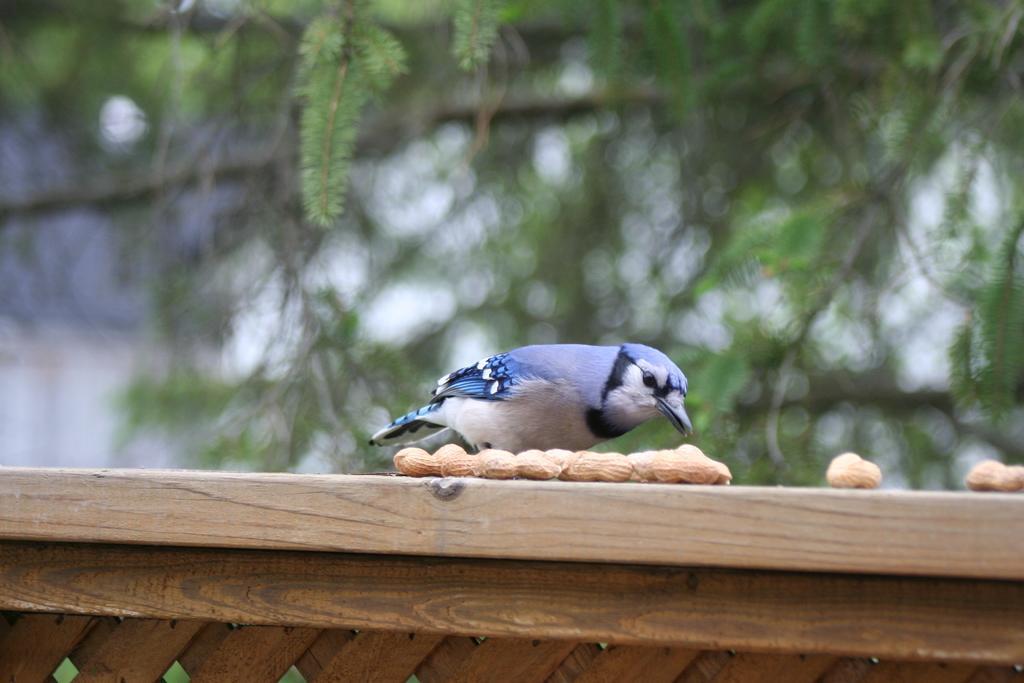How would you summarize this image in a sentence or two? In this image I can see the bird which is in blue and white color. In-front of the bird I can see the food and the bird is on the wooden object. In the background I can see many trees and the background is blurred. 